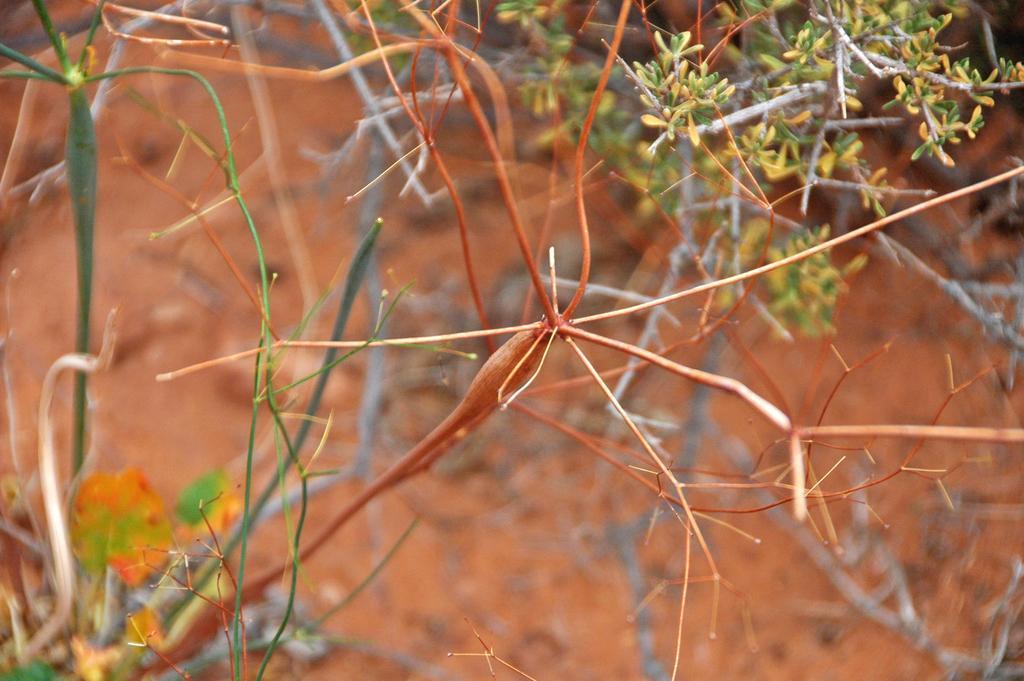Could you give a brief overview of what you see in this image? In the picture I can see the stems of plants. I can see small green leaves on the top right side of the picture. 